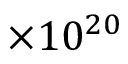<formula> <loc_0><loc_0><loc_500><loc_500>\times 1 0 ^ { 2 0 }</formula> 